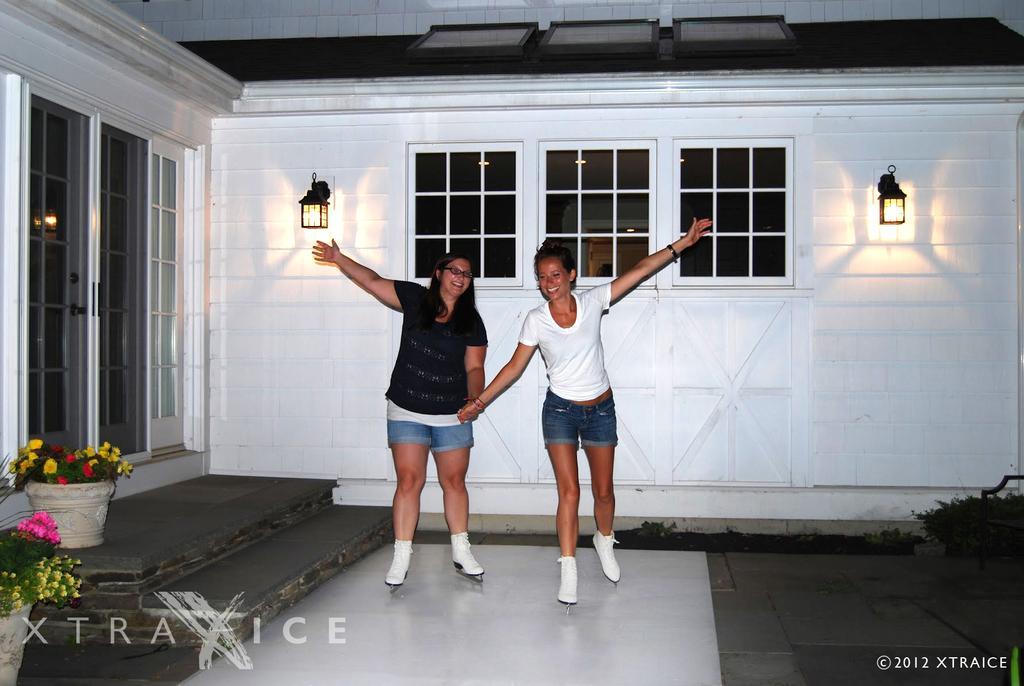In one or two sentences, can you explain what this image depicts? In this image, we can see two women are holding hands with each other and smiling. They are skating on a white surface. On the left side, we can see stairs, flowers, plants with pots, glass doors. Background we can see wall, lights, glass windows and few objects. At the bottom of the image, we can see watermark in the image. 